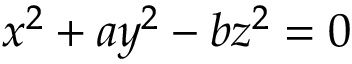<formula> <loc_0><loc_0><loc_500><loc_500>x ^ { 2 } + a y ^ { 2 } - b z ^ { 2 } = 0</formula> 